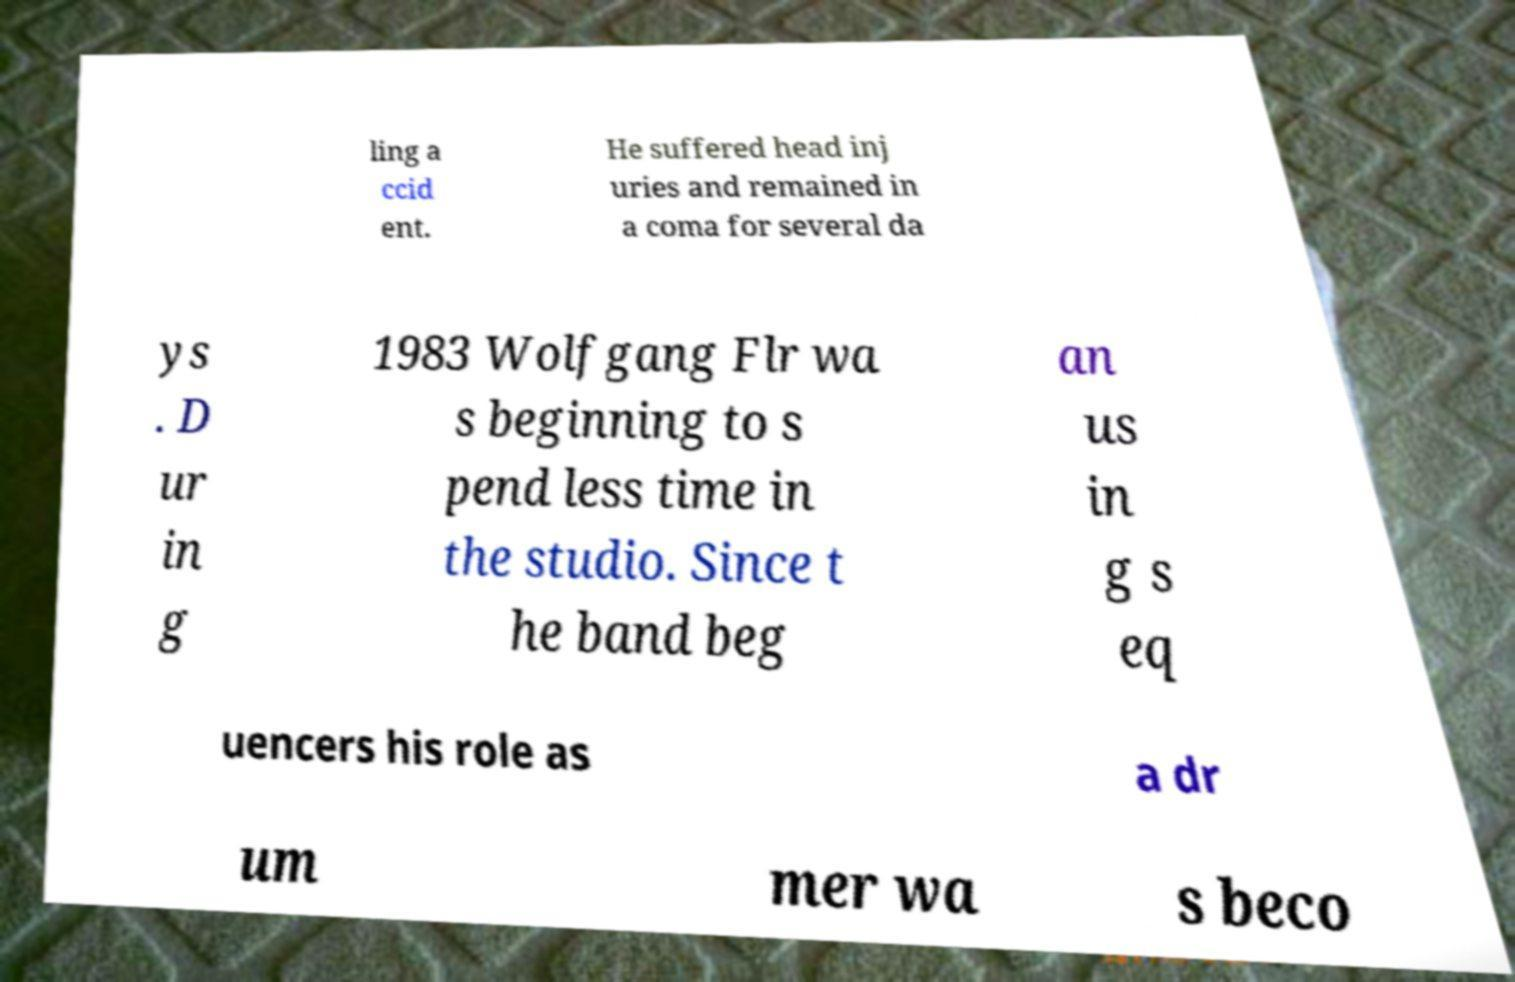For documentation purposes, I need the text within this image transcribed. Could you provide that? ling a ccid ent. He suffered head inj uries and remained in a coma for several da ys . D ur in g 1983 Wolfgang Flr wa s beginning to s pend less time in the studio. Since t he band beg an us in g s eq uencers his role as a dr um mer wa s beco 